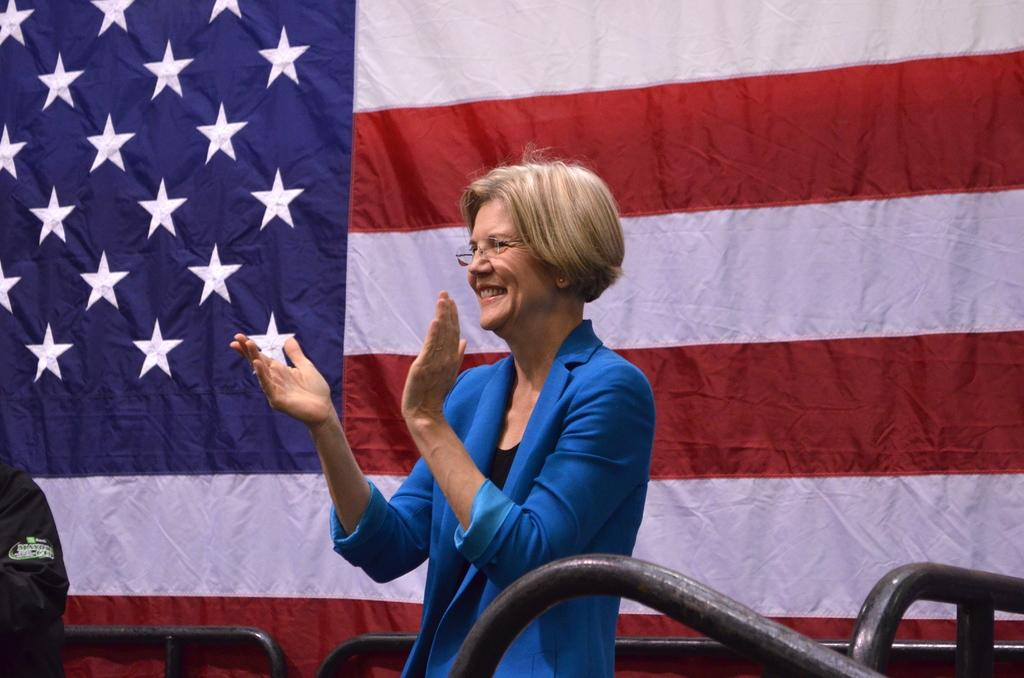How many people are in the foreground of the image? There are two persons in the foreground of the image. What objects are present in the foreground of the image? Metal rods are present in the foreground of the image. What can be seen in the background of the image? There is a flag in the background of the image. Can you describe the setting where the image might have been taken? The image may have been taken on a stage. What type of songs are being sung by the persons in the image? There is no indication in the image that the persons are singing songs, so it cannot be determined from the picture. 